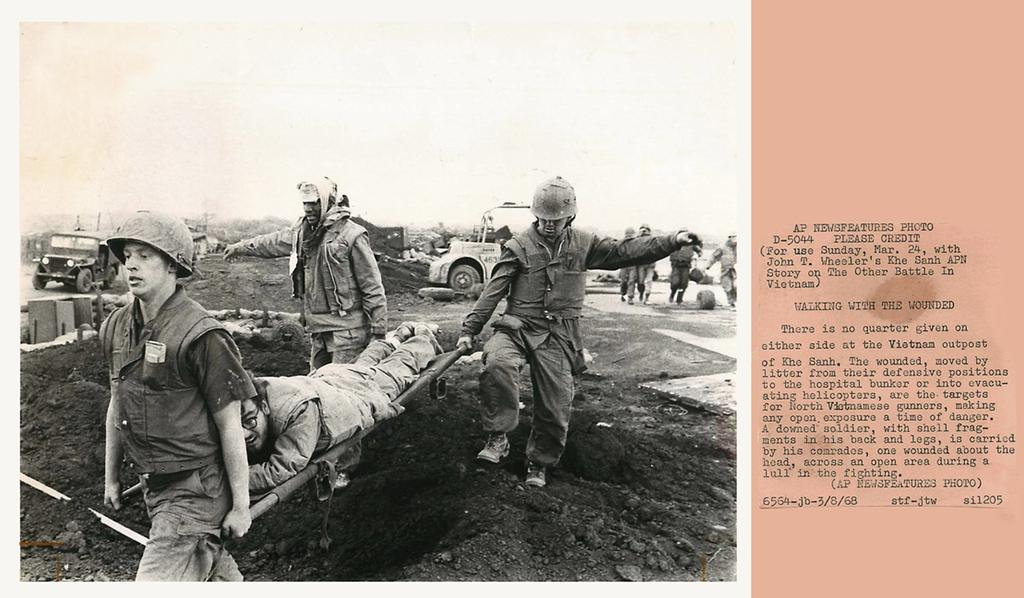How many people are in the group shown in the image? There is a group of people in the image. What are some of the people in the group doing? Some people in the group are carrying a stretcher. Who is on the stretcher? There is a person on the stretcher. What can be seen in the background of the image? There are vehicles visible in the background of the image. What type of letter is being delivered to the person on the stretcher in the image? There is no letter being delivered to the person on the stretcher in the image. Is there a veil covering the person on the stretcher in the image? No, there is no veil covering the person on the stretcher in the image. 